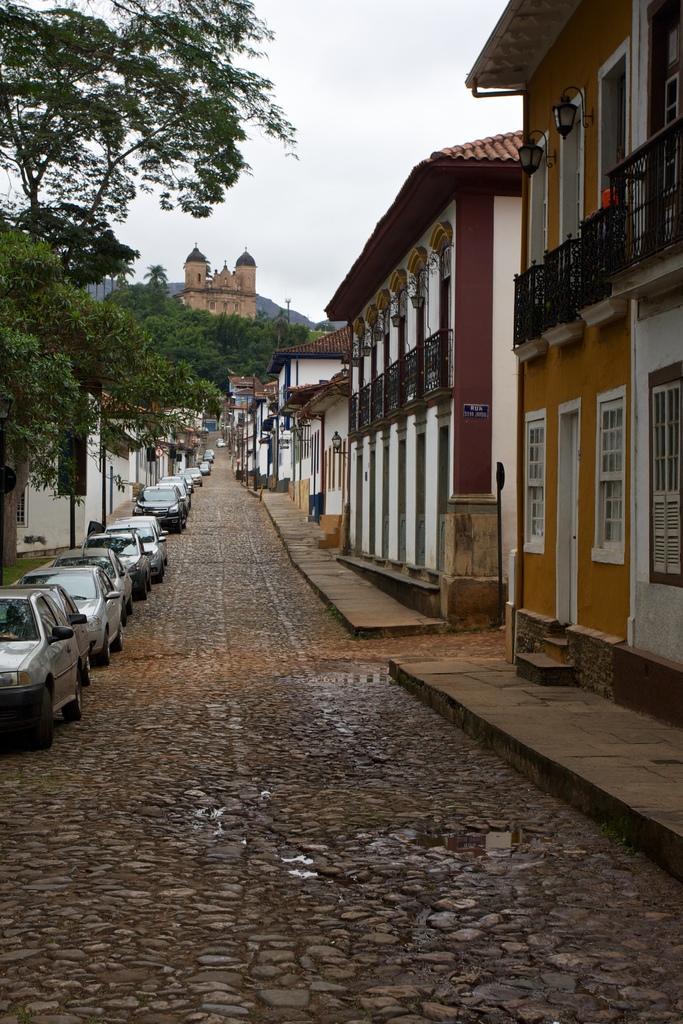Please provide a concise description of this image. In this image there is a street view, on the street there are cars parked, on the either side of the street there are trees and buildings. 